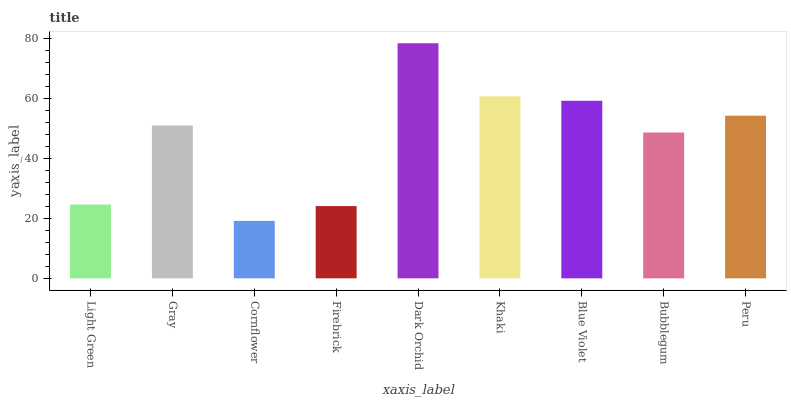Is Cornflower the minimum?
Answer yes or no. Yes. Is Dark Orchid the maximum?
Answer yes or no. Yes. Is Gray the minimum?
Answer yes or no. No. Is Gray the maximum?
Answer yes or no. No. Is Gray greater than Light Green?
Answer yes or no. Yes. Is Light Green less than Gray?
Answer yes or no. Yes. Is Light Green greater than Gray?
Answer yes or no. No. Is Gray less than Light Green?
Answer yes or no. No. Is Gray the high median?
Answer yes or no. Yes. Is Gray the low median?
Answer yes or no. Yes. Is Dark Orchid the high median?
Answer yes or no. No. Is Bubblegum the low median?
Answer yes or no. No. 